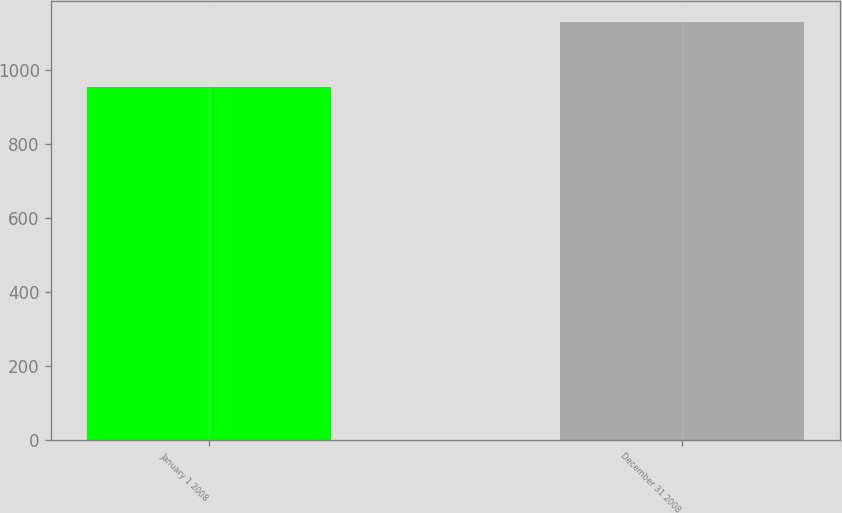Convert chart to OTSL. <chart><loc_0><loc_0><loc_500><loc_500><bar_chart><fcel>January 1 2008<fcel>December 31 2008<nl><fcel>954.4<fcel>1128.9<nl></chart> 